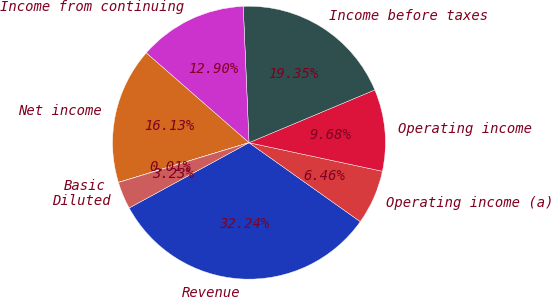Convert chart. <chart><loc_0><loc_0><loc_500><loc_500><pie_chart><fcel>Revenue<fcel>Operating income (a)<fcel>Operating income<fcel>Income before taxes<fcel>Income from continuing<fcel>Net income<fcel>Basic<fcel>Diluted<nl><fcel>32.24%<fcel>6.46%<fcel>9.68%<fcel>19.35%<fcel>12.9%<fcel>16.13%<fcel>0.01%<fcel>3.23%<nl></chart> 